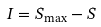<formula> <loc_0><loc_0><loc_500><loc_500>I = { S } _ { \max } - { S }</formula> 